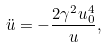Convert formula to latex. <formula><loc_0><loc_0><loc_500><loc_500>\ddot { u } = - \frac { 2 \gamma ^ { 2 } u ^ { 4 } _ { 0 } } { u } ,</formula> 